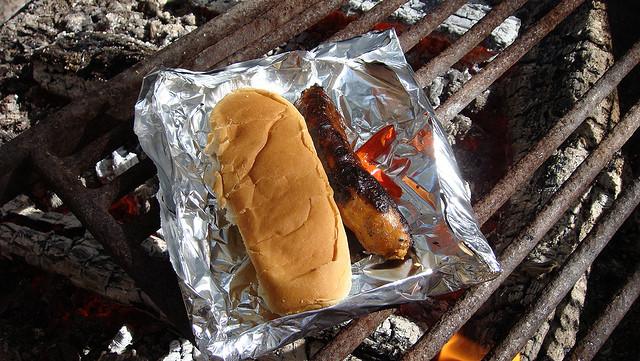What is the hot dog on?
Concise answer only. Foil. Is this edible object considered a street food?
Short answer required. Yes. Is the grill charcoal or gas?
Keep it brief. Charcoal. 